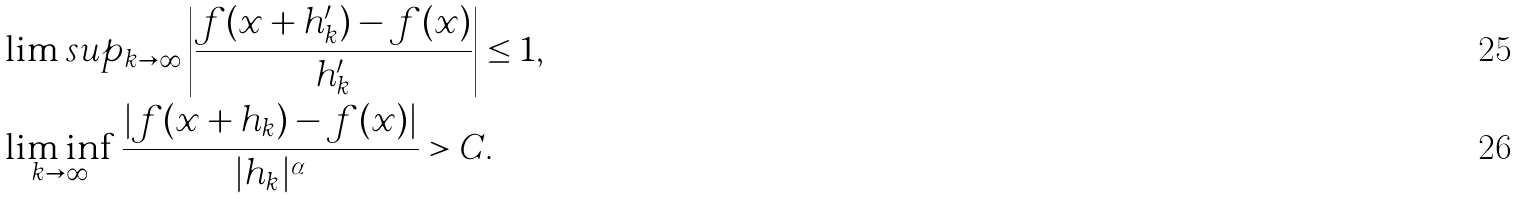<formula> <loc_0><loc_0><loc_500><loc_500>& \lim s u p _ { k \rightarrow \infty } \left | \frac { f ( x + h ^ { \prime } _ { k } ) - f ( x ) } { h ^ { \prime } _ { k } } \right | \leq 1 , \\ & \liminf _ { k \rightarrow \infty } \frac { | f ( x + h _ { k } ) - f ( x ) | } { | h _ { k } | ^ { \alpha } } > C .</formula> 